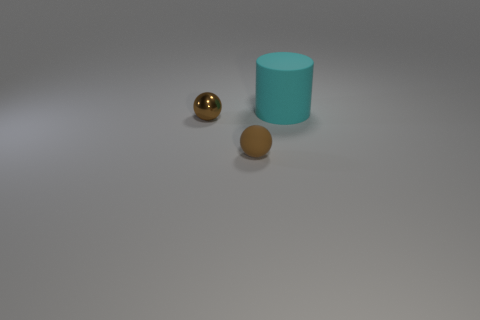What is the color of the other small object that is the same shape as the brown shiny object?
Your answer should be very brief. Brown. There is a tiny sphere that is in front of the tiny brown shiny ball; what material is it?
Ensure brevity in your answer.  Rubber. Is the number of small brown things that are on the left side of the large rubber thing less than the number of objects?
Your answer should be compact. Yes. There is a tiny brown thing behind the rubber object that is in front of the large cyan thing; what shape is it?
Offer a terse response. Sphere. The metal thing has what color?
Provide a short and direct response. Brown. What number of other objects are the same size as the brown metallic ball?
Make the answer very short. 1. There is a object that is both to the right of the metallic object and behind the brown matte sphere; what is it made of?
Give a very brief answer. Rubber. Is the size of the matte object in front of the matte cylinder the same as the shiny thing?
Offer a very short reply. Yes. Is the metal thing the same color as the rubber ball?
Your answer should be compact. Yes. How many objects are both behind the brown rubber ball and left of the cyan rubber cylinder?
Make the answer very short. 1. 